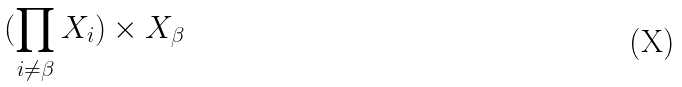<formula> <loc_0><loc_0><loc_500><loc_500>( \prod _ { i \ne \beta } X _ { i } ) \times X _ { \beta }</formula> 